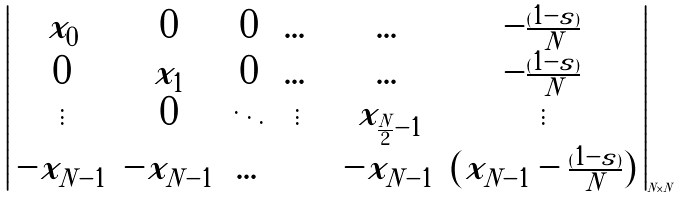Convert formula to latex. <formula><loc_0><loc_0><loc_500><loc_500>\left | \begin{array} { c c c c c c c } x _ { 0 } & 0 & 0 & \dots & & \dots & - \frac { ( 1 - s ) } { N } \\ 0 & x _ { 1 } & 0 & \dots & & \dots & - \frac { ( 1 - s ) } { N } \\ \vdots & 0 & \ddots & \vdots & & x _ { \frac { N } { 2 } - 1 } & \vdots \\ - x _ { N - 1 } & - x _ { N - 1 } & \dots & & & - x _ { N - 1 } & ( x _ { N - 1 } - \frac { ( 1 - s ) } { N } ) \\ \end{array} \right | _ { N \times N }</formula> 